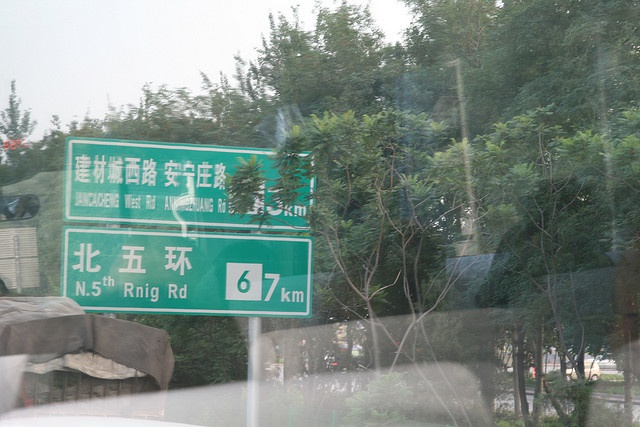Describe the objects in this image and their specific colors. I can see a car in white, ivory, gray, darkgray, and tan tones in this image. 